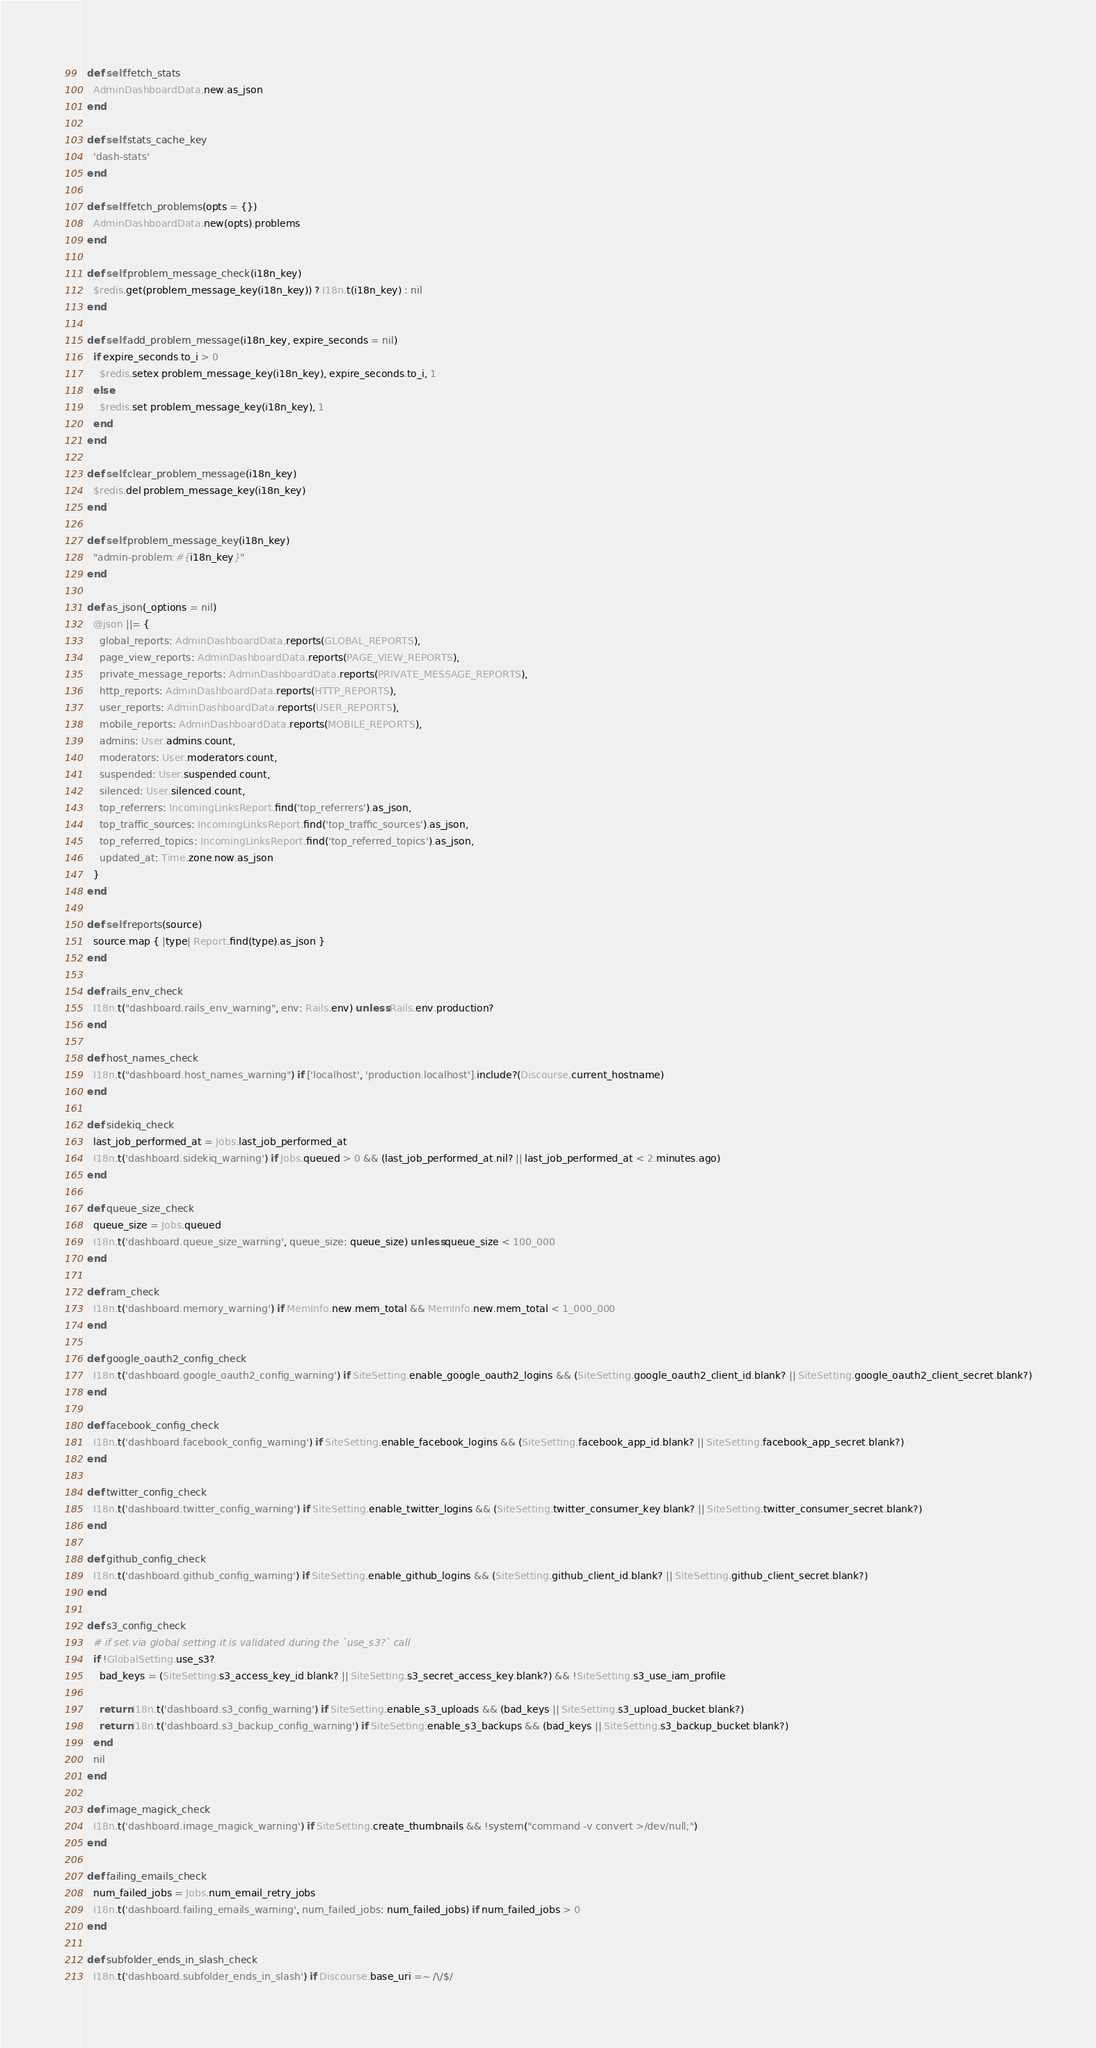Convert code to text. <code><loc_0><loc_0><loc_500><loc_500><_Ruby_>
  def self.fetch_stats
    AdminDashboardData.new.as_json
  end

  def self.stats_cache_key
    'dash-stats'
  end

  def self.fetch_problems(opts = {})
    AdminDashboardData.new(opts).problems
  end

  def self.problem_message_check(i18n_key)
    $redis.get(problem_message_key(i18n_key)) ? I18n.t(i18n_key) : nil
  end

  def self.add_problem_message(i18n_key, expire_seconds = nil)
    if expire_seconds.to_i > 0
      $redis.setex problem_message_key(i18n_key), expire_seconds.to_i, 1
    else
      $redis.set problem_message_key(i18n_key), 1
    end
  end

  def self.clear_problem_message(i18n_key)
    $redis.del problem_message_key(i18n_key)
  end

  def self.problem_message_key(i18n_key)
    "admin-problem:#{i18n_key}"
  end

  def as_json(_options = nil)
    @json ||= {
      global_reports: AdminDashboardData.reports(GLOBAL_REPORTS),
      page_view_reports: AdminDashboardData.reports(PAGE_VIEW_REPORTS),
      private_message_reports: AdminDashboardData.reports(PRIVATE_MESSAGE_REPORTS),
      http_reports: AdminDashboardData.reports(HTTP_REPORTS),
      user_reports: AdminDashboardData.reports(USER_REPORTS),
      mobile_reports: AdminDashboardData.reports(MOBILE_REPORTS),
      admins: User.admins.count,
      moderators: User.moderators.count,
      suspended: User.suspended.count,
      silenced: User.silenced.count,
      top_referrers: IncomingLinksReport.find('top_referrers').as_json,
      top_traffic_sources: IncomingLinksReport.find('top_traffic_sources').as_json,
      top_referred_topics: IncomingLinksReport.find('top_referred_topics').as_json,
      updated_at: Time.zone.now.as_json
    }
  end

  def self.reports(source)
    source.map { |type| Report.find(type).as_json }
  end

  def rails_env_check
    I18n.t("dashboard.rails_env_warning", env: Rails.env) unless Rails.env.production?
  end

  def host_names_check
    I18n.t("dashboard.host_names_warning") if ['localhost', 'production.localhost'].include?(Discourse.current_hostname)
  end

  def sidekiq_check
    last_job_performed_at = Jobs.last_job_performed_at
    I18n.t('dashboard.sidekiq_warning') if Jobs.queued > 0 && (last_job_performed_at.nil? || last_job_performed_at < 2.minutes.ago)
  end

  def queue_size_check
    queue_size = Jobs.queued
    I18n.t('dashboard.queue_size_warning', queue_size: queue_size) unless queue_size < 100_000
  end

  def ram_check
    I18n.t('dashboard.memory_warning') if MemInfo.new.mem_total && MemInfo.new.mem_total < 1_000_000
  end

  def google_oauth2_config_check
    I18n.t('dashboard.google_oauth2_config_warning') if SiteSetting.enable_google_oauth2_logins && (SiteSetting.google_oauth2_client_id.blank? || SiteSetting.google_oauth2_client_secret.blank?)
  end

  def facebook_config_check
    I18n.t('dashboard.facebook_config_warning') if SiteSetting.enable_facebook_logins && (SiteSetting.facebook_app_id.blank? || SiteSetting.facebook_app_secret.blank?)
  end

  def twitter_config_check
    I18n.t('dashboard.twitter_config_warning') if SiteSetting.enable_twitter_logins && (SiteSetting.twitter_consumer_key.blank? || SiteSetting.twitter_consumer_secret.blank?)
  end

  def github_config_check
    I18n.t('dashboard.github_config_warning') if SiteSetting.enable_github_logins && (SiteSetting.github_client_id.blank? || SiteSetting.github_client_secret.blank?)
  end

  def s3_config_check
    # if set via global setting it is validated during the `use_s3?` call
    if !GlobalSetting.use_s3?
      bad_keys = (SiteSetting.s3_access_key_id.blank? || SiteSetting.s3_secret_access_key.blank?) && !SiteSetting.s3_use_iam_profile

      return I18n.t('dashboard.s3_config_warning') if SiteSetting.enable_s3_uploads && (bad_keys || SiteSetting.s3_upload_bucket.blank?)
      return I18n.t('dashboard.s3_backup_config_warning') if SiteSetting.enable_s3_backups && (bad_keys || SiteSetting.s3_backup_bucket.blank?)
    end
    nil
  end

  def image_magick_check
    I18n.t('dashboard.image_magick_warning') if SiteSetting.create_thumbnails && !system("command -v convert >/dev/null;")
  end

  def failing_emails_check
    num_failed_jobs = Jobs.num_email_retry_jobs
    I18n.t('dashboard.failing_emails_warning', num_failed_jobs: num_failed_jobs) if num_failed_jobs > 0
  end

  def subfolder_ends_in_slash_check
    I18n.t('dashboard.subfolder_ends_in_slash') if Discourse.base_uri =~ /\/$/</code> 